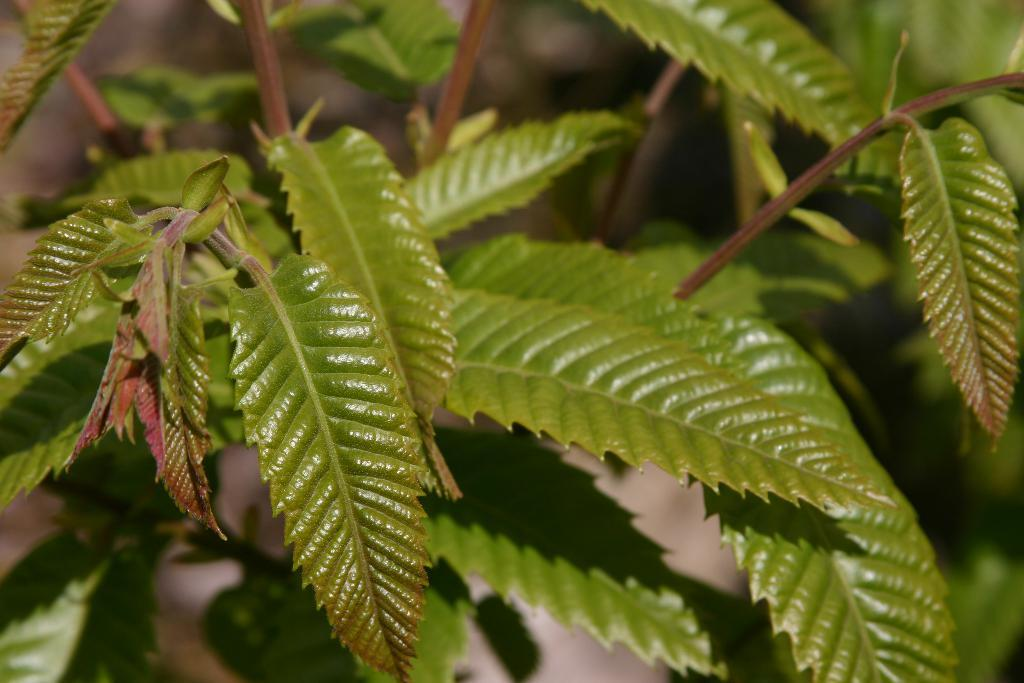Where was the image taken? The image was taken outdoors. What can be seen in the image besides the outdoor setting? There is a plant in the image. Can you describe the plant in the image? The plant has stems and green leaves. How many crayons are scattered around the plant in the image? There are no crayons present in the image. Is there a boat visible in the image? No, there is no boat visible in the image. 